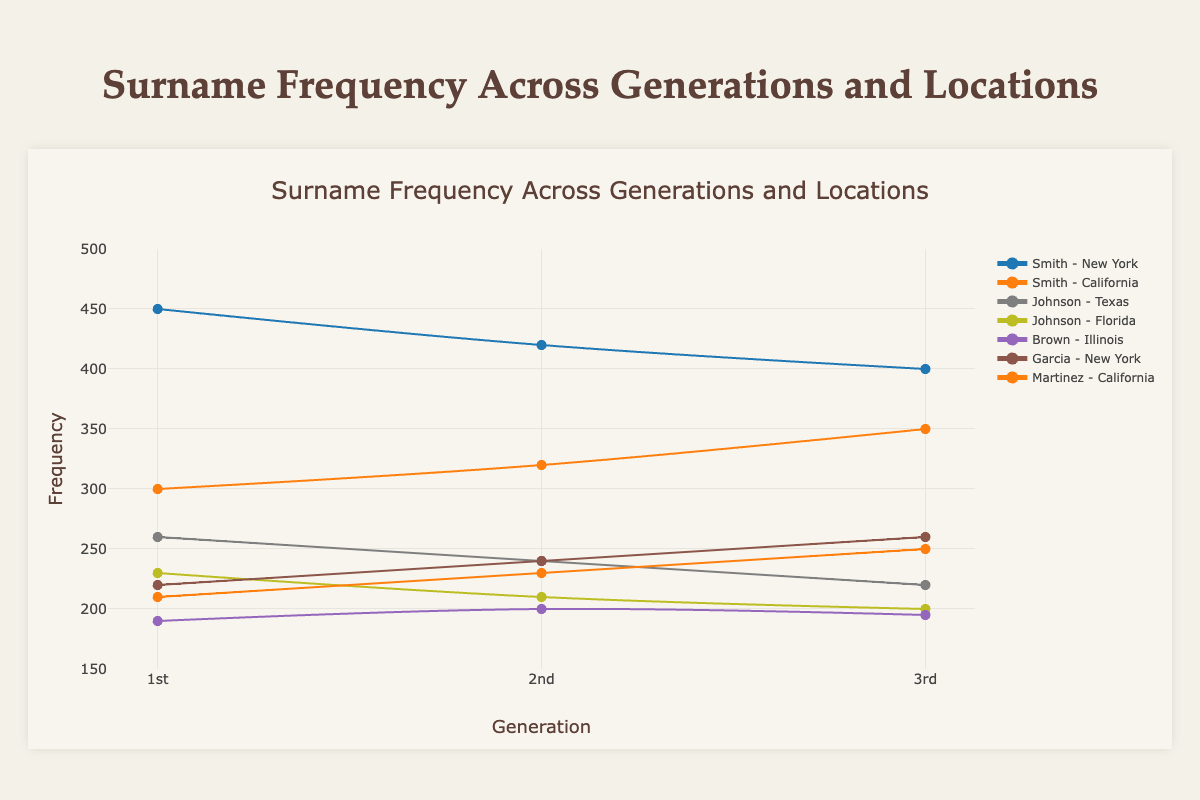What is the title of the figure? The title is displayed prominently at the top of the chart.
Answer: Surname Frequency Across Generations and Locations How many generations are shown in the figure? The x-axis is labeled "Generation" and has ticks labeled "1st," "2nd," and "3rd."
Answer: 3 Which surname has the highest frequency in the 1st generation in New York? By looking at the data points for New York in the 1st generation and comparing the values, we see that Smith has the highest frequency.
Answer: Smith What is the frequency of the surname Martinez in California in the 2nd generation? Locate the data point for Martinez in California in the 2nd generation, which shows a frequency of 230.
Answer: 230 Which surname shows a consistent increase in frequency over the generations in New York? By examining the trend lines for each surname in New York, Garcia shows a consistent increase in frequency across the generations.
Answer: Garcia How does the frequency of Smith in California change from the 1st to the 3rd generation? Look at the data points for Smith in California: the frequency increases from 300 in the 1st generation to 350 in the 3rd generation.
Answer: It increases Which location has the lowest frequency for the surname Johnson in the 3rd generation? Compare the data points for Johnson in the 3rd generation across all locations; Florida has the lowest frequency at 200.
Answer: Florida What is the average frequency of the surname Brown across all generations in Illinois? Sum the frequencies for Brown in Illinois across all three generations (190 + 200 + 195) and then divide by 3 for the average.
Answer: 195 How does the trend for the surname Johnson in Texas compare to Florida over the generations? Both exhibit a decreasing trend. In Texas, the frequency drops from 260 to 220, and in Florida, it drops from 230 to 200.
Answer: Both decrease What is the total frequency of the surname Smith in New York over all generations? Add the frequencies of Smith in New York for all generations (450 + 420 + 400) to get the total frequency.
Answer: 1270 